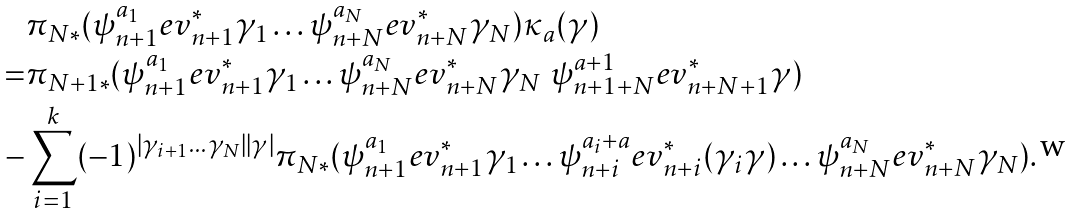<formula> <loc_0><loc_0><loc_500><loc_500>& \pi _ { N * } ( \psi _ { n + 1 } ^ { a _ { 1 } } e v _ { n + 1 } ^ { * } \gamma _ { 1 } \dots \psi _ { n + N } ^ { a _ { N } } e v _ { n + N } ^ { * } \gamma _ { N } ) \kappa _ { a } ( \gamma ) \\ = & \pi _ { N + 1 * } ( \psi _ { n + 1 } ^ { a _ { 1 } } e v _ { n + 1 } ^ { * } \gamma _ { 1 } \dots \psi _ { n + N } ^ { a _ { N } } e v _ { n + N } ^ { * } \gamma _ { N } \ \psi _ { n + 1 + N } ^ { a + 1 } e v _ { n + N + 1 } ^ { * } \gamma ) \\ - & \sum _ { i = 1 } ^ { k } ( - 1 ) ^ { | \gamma _ { i + 1 } \dots \gamma _ { N } | | \gamma | } \pi _ { N * } ( \psi _ { n + 1 } ^ { a _ { 1 } } e v _ { n + 1 } ^ { * } \gamma _ { 1 } \dots \psi _ { n + i } ^ { a _ { i } + a } e v _ { n + i } ^ { * } ( \gamma _ { i } \gamma ) \dots \psi _ { n + N } ^ { a _ { N } } e v _ { n + N } ^ { * } \gamma _ { N } ) .</formula> 